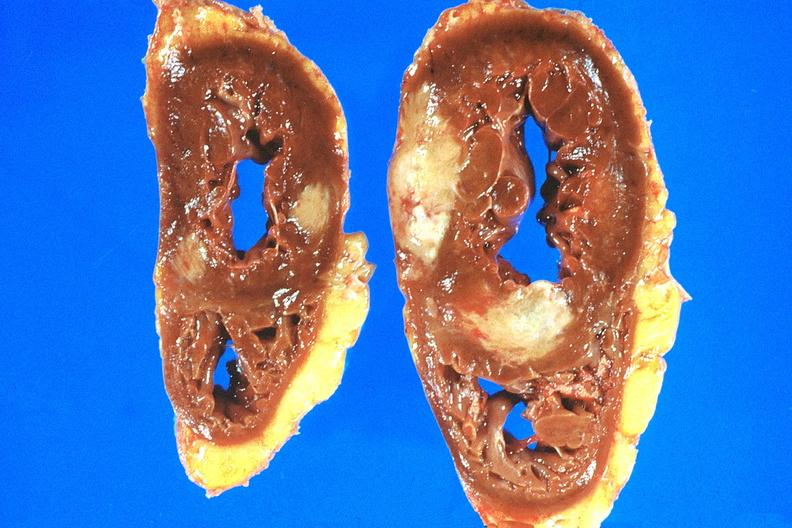what does this image show?
Answer the question using a single word or phrase. Heart 